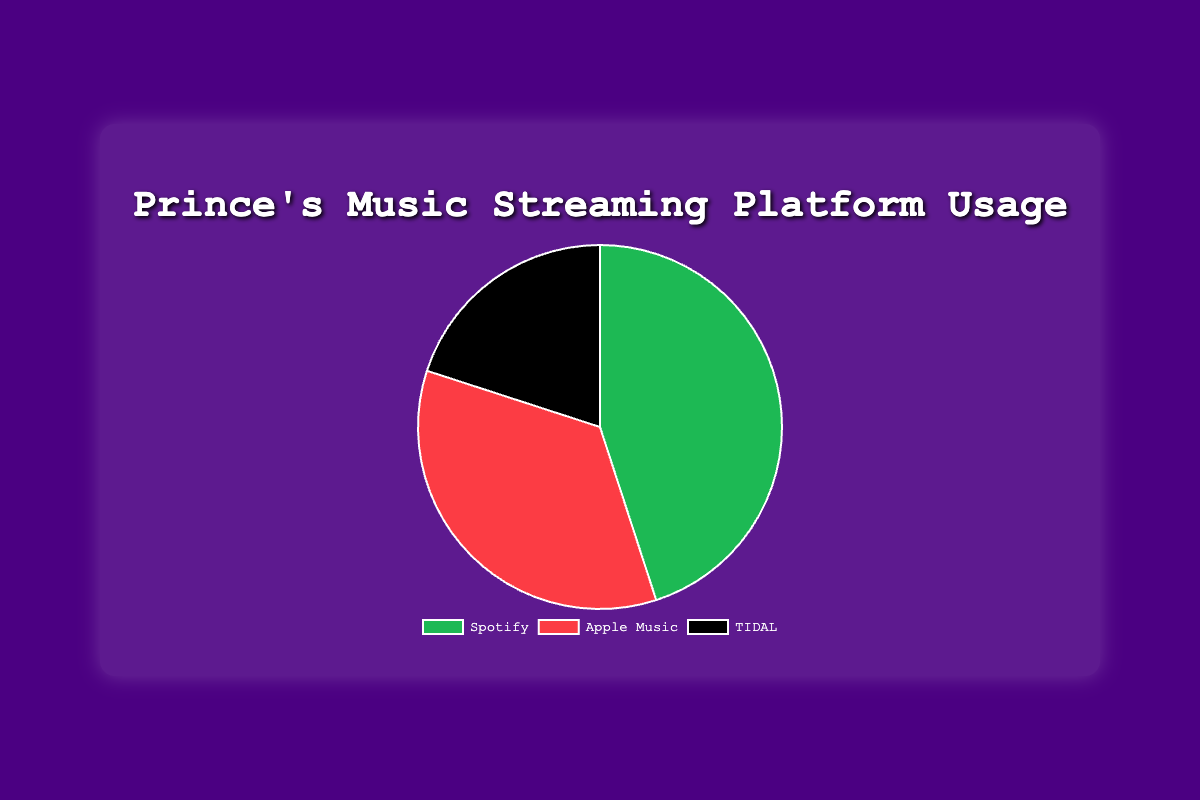What percentage of listeners stream Prince's music on Spotify? The chart shows that the segment labeled 'Spotify' accounts for 45% of the total streaming platform usage.
Answer: 45% Which streaming platform has the lowest usage percentage for Prince's music? The chart indicates that 'TIDAL' has the smallest segment with 20% of the total streaming platform usage.
Answer: TIDAL How much higher is the usage percentage for Spotify compared to TIDAL? Spotify has a usage percentage of 45% and TIDAL has 20%. Subtract TIDAL's percentage from Spotify's: 45% - 20% = 25%.
Answer: 25% What is the total percentage of usage for Apple Music and TIDAL combined? Apple Music has 35% and TIDAL has 20%. Adding these together: 35% + 20% = 55%.
Answer: 55% Which segment color represents Apple Music? The chart uses distinct colors for each segment, with Apple Music represented by a red section.
Answer: Red Is the percentage of users who stream Prince's music on Apple Music greater than those on TIDAL? The chart shows Apple Music at 35% and TIDAL at 20%. Since 35% is greater than 20%, Apple Music has a higher percentage.
Answer: Yes What is the difference between the highest and lowest usage percentages? The highest usage percentage is for Spotify at 45% and the lowest is for TIDAL at 20%. The difference is 45% - 20% = 25%.
Answer: 25% If Apple Music and TIDAL usage are combined, do they surpass Spotify's usage? Apple Music combined with TIDAL usage is 35% + 20% = 55%, which is greater than Spotify's 45%.
Answer: Yes What is the average usage percentage across all three platforms? The percentages for Spotify, Apple Music, and TIDAL are 45%, 35%, and 20% respectively. The average is (45% + 35% + 20%) / 3 = 33.33%.
Answer: 33.33% 